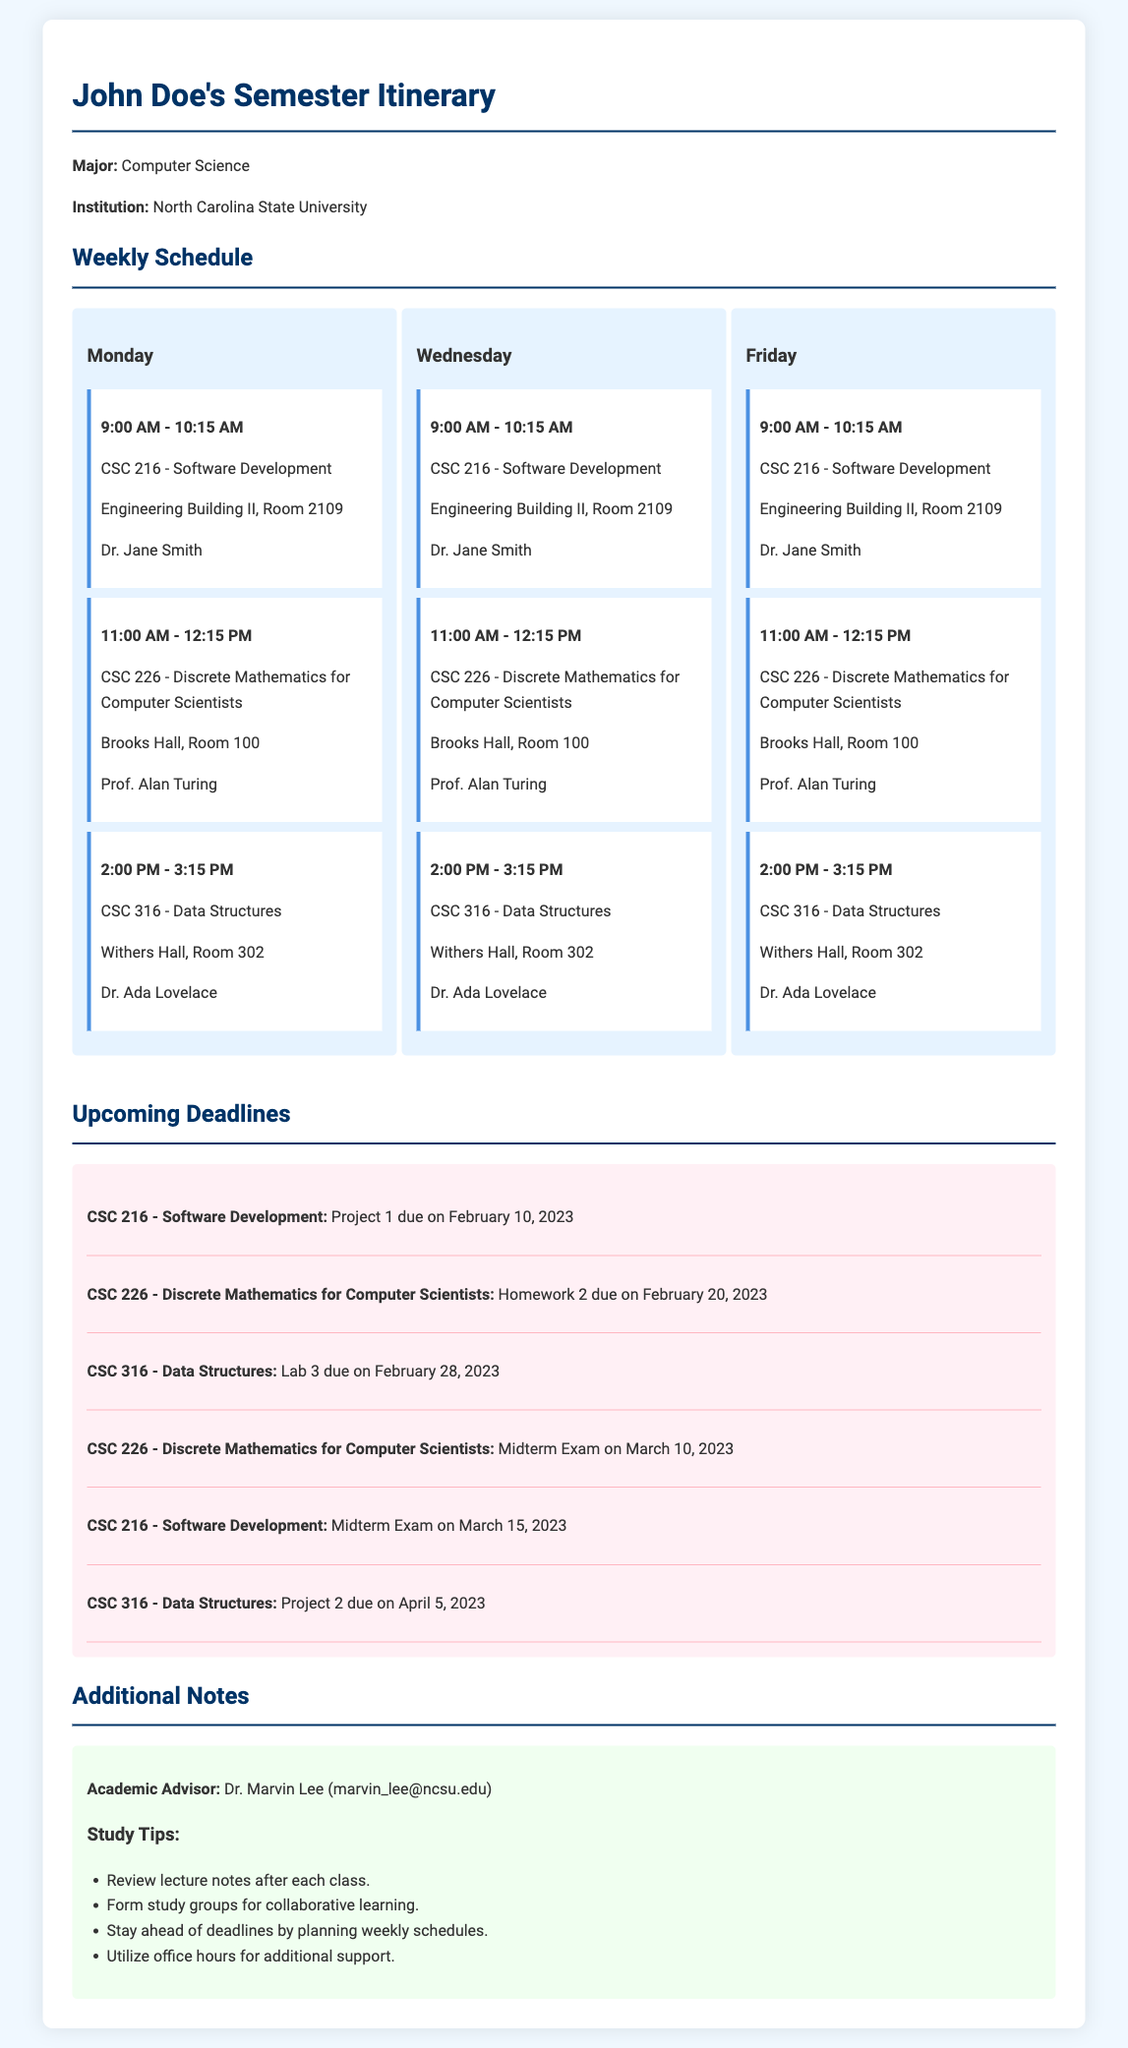What is the major of John Doe? The major of John Doe is mentioned in the document, which is Computer Science.
Answer: Computer Science Who teaches CSC 316? The instructor for CSC 316 is specified in the schedule section of the document, which is Dr. Ada Lovelace.
Answer: Dr. Ada Lovelace When is the due date for Project 1 in CSC 216? The due date for Project 1 in CSC 216 is listed in the deadlines section of the document.
Answer: February 10, 2023 How many classes are scheduled on Monday? The number of classes on Monday is counted from the schedule provided.
Answer: 3 What is the title of the second class on Wednesday? The title of the second class on Wednesday is outlined in the schedule section of the document.
Answer: Discrete Mathematics for Computer Scientists What deadline is associated with CSC 226 on March 10, 2023? The deadline associated with CSC 226 on March 10 is found in the upcoming deadlines section of the document.
Answer: Midterm Exam Who is the academic advisor? The academic advisor is explicitly mentioned in the additional notes section of the document.
Answer: Dr. Marvin Lee What is one study tip mentioned in the document? One of the study tips is listed under the notes section, which provides strategies for effective studying.
Answer: Review lecture notes after each class 